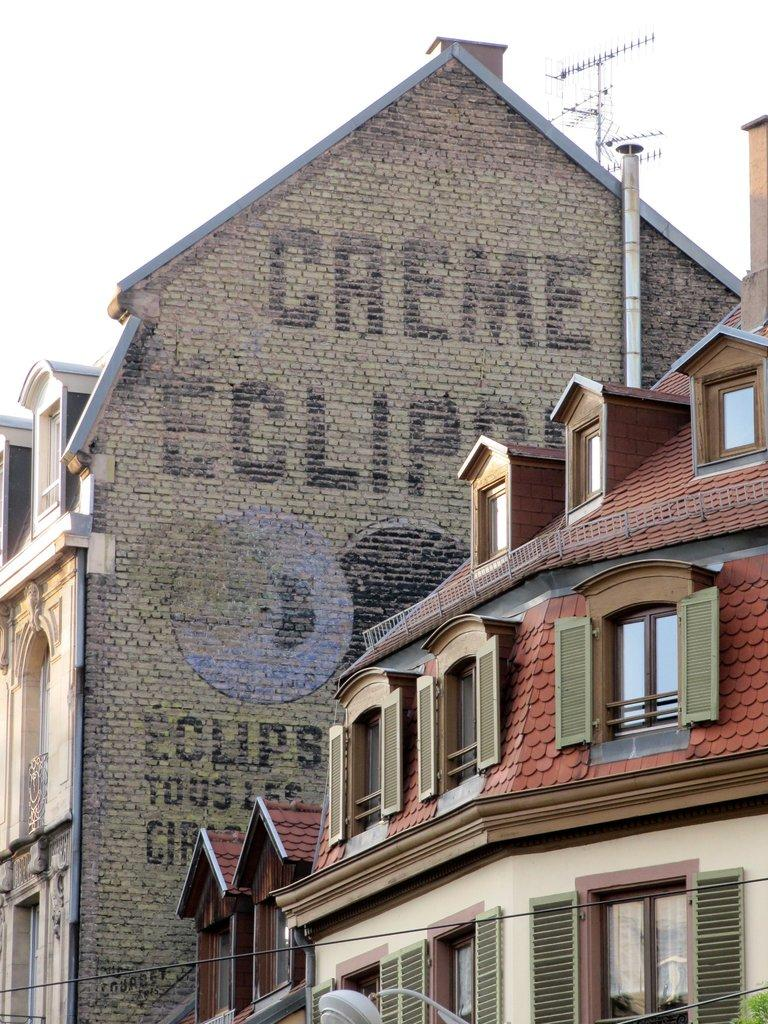How many buildings with windows can be seen in the image? There are two buildings with windows in the image. What is written on the wall of one of the buildings? There are words on the wall of one of the buildings. What other structures can be seen in the image? Cables and an antenna are visible in the image. What is visible in the background of the image? The sky is visible in the background of the image. How many books can be seen on the spade in the image? There are no books or spades present in the image. 